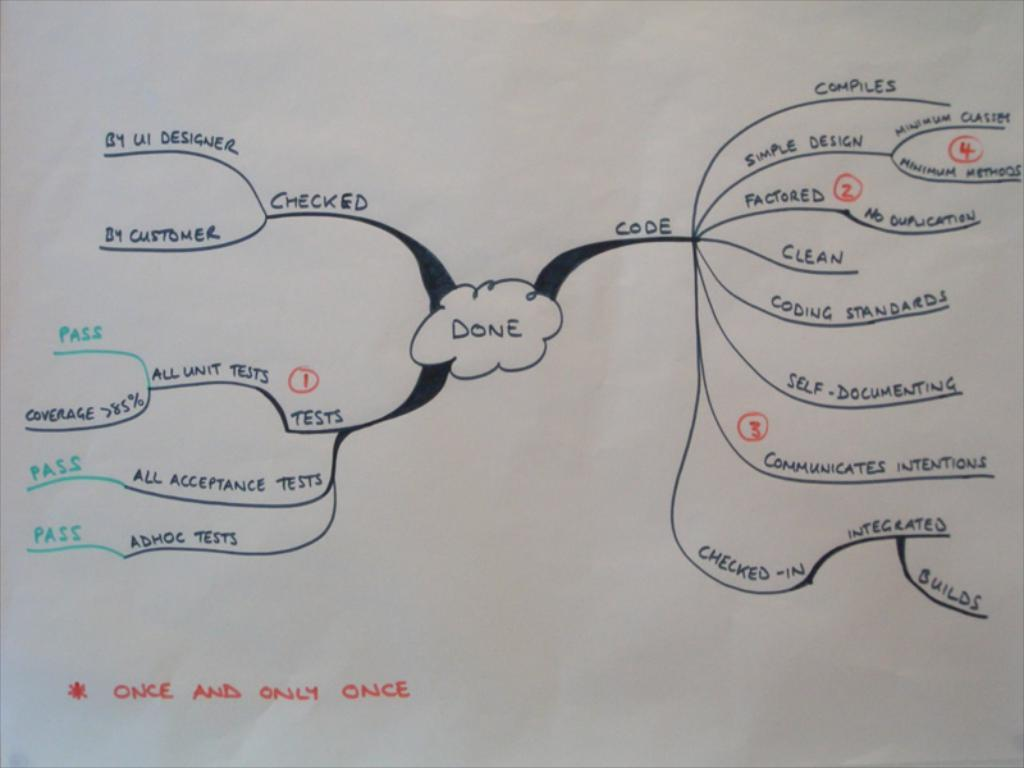<image>
Create a compact narrative representing the image presented. A diagram indicates that all unit tests are once and only once. 